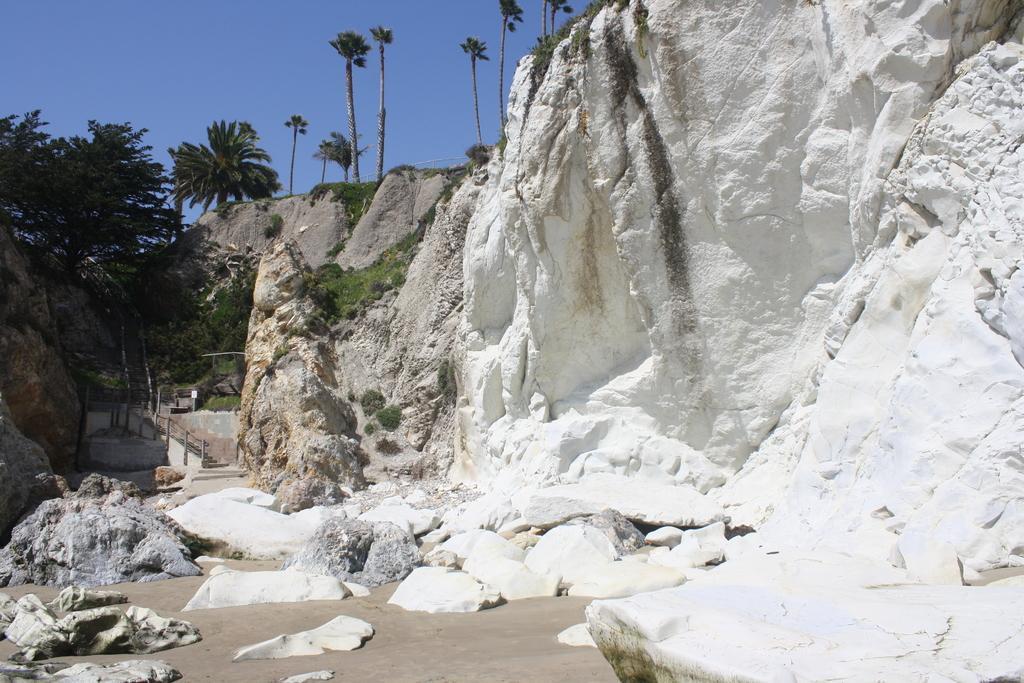Could you give a brief overview of what you see in this image? In this image there is the sky, there are trees, there is a rock truncated towards the right of the image, there are objects on the ground, there is a tree truncated towards the left of the image, there are rocks truncated towards the left of the image, there are staircase, there is board, there are plants. 